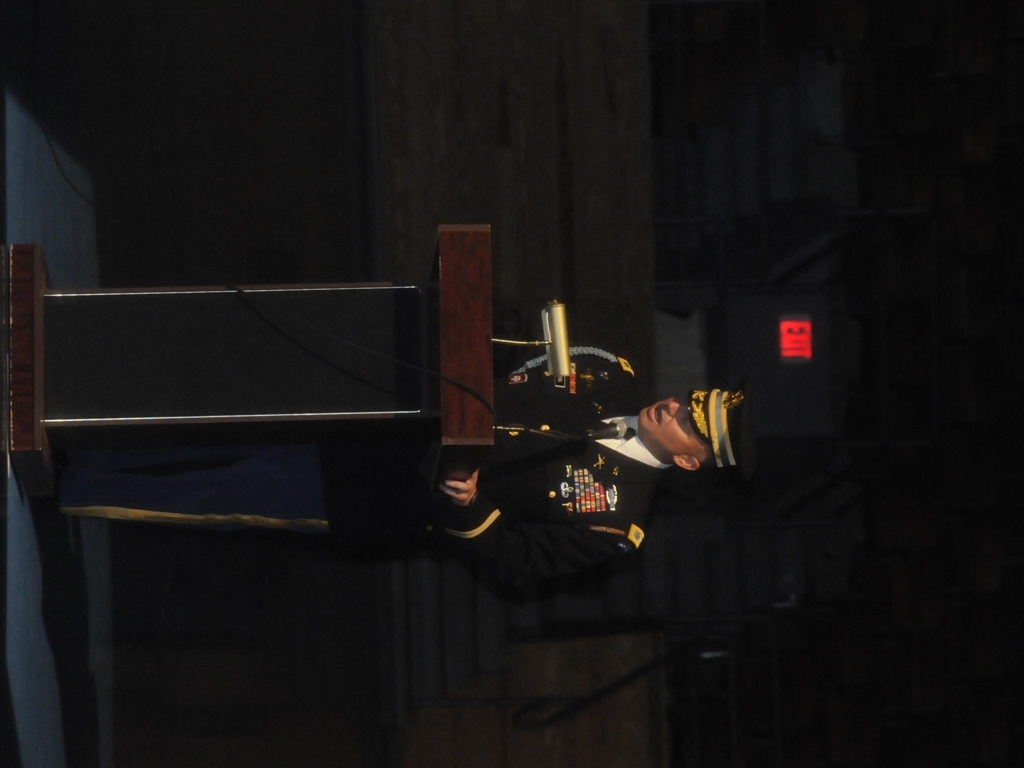What does the setting of the photo suggest about the event taking place? The setting, which includes a large podium and formal attire, suggests an official or ceremonial event, possibly within a military context. 